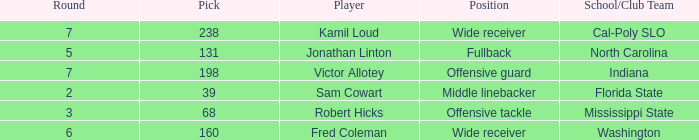Which Round has a School/Club Team of cal-poly slo, and a Pick smaller than 238? None. 